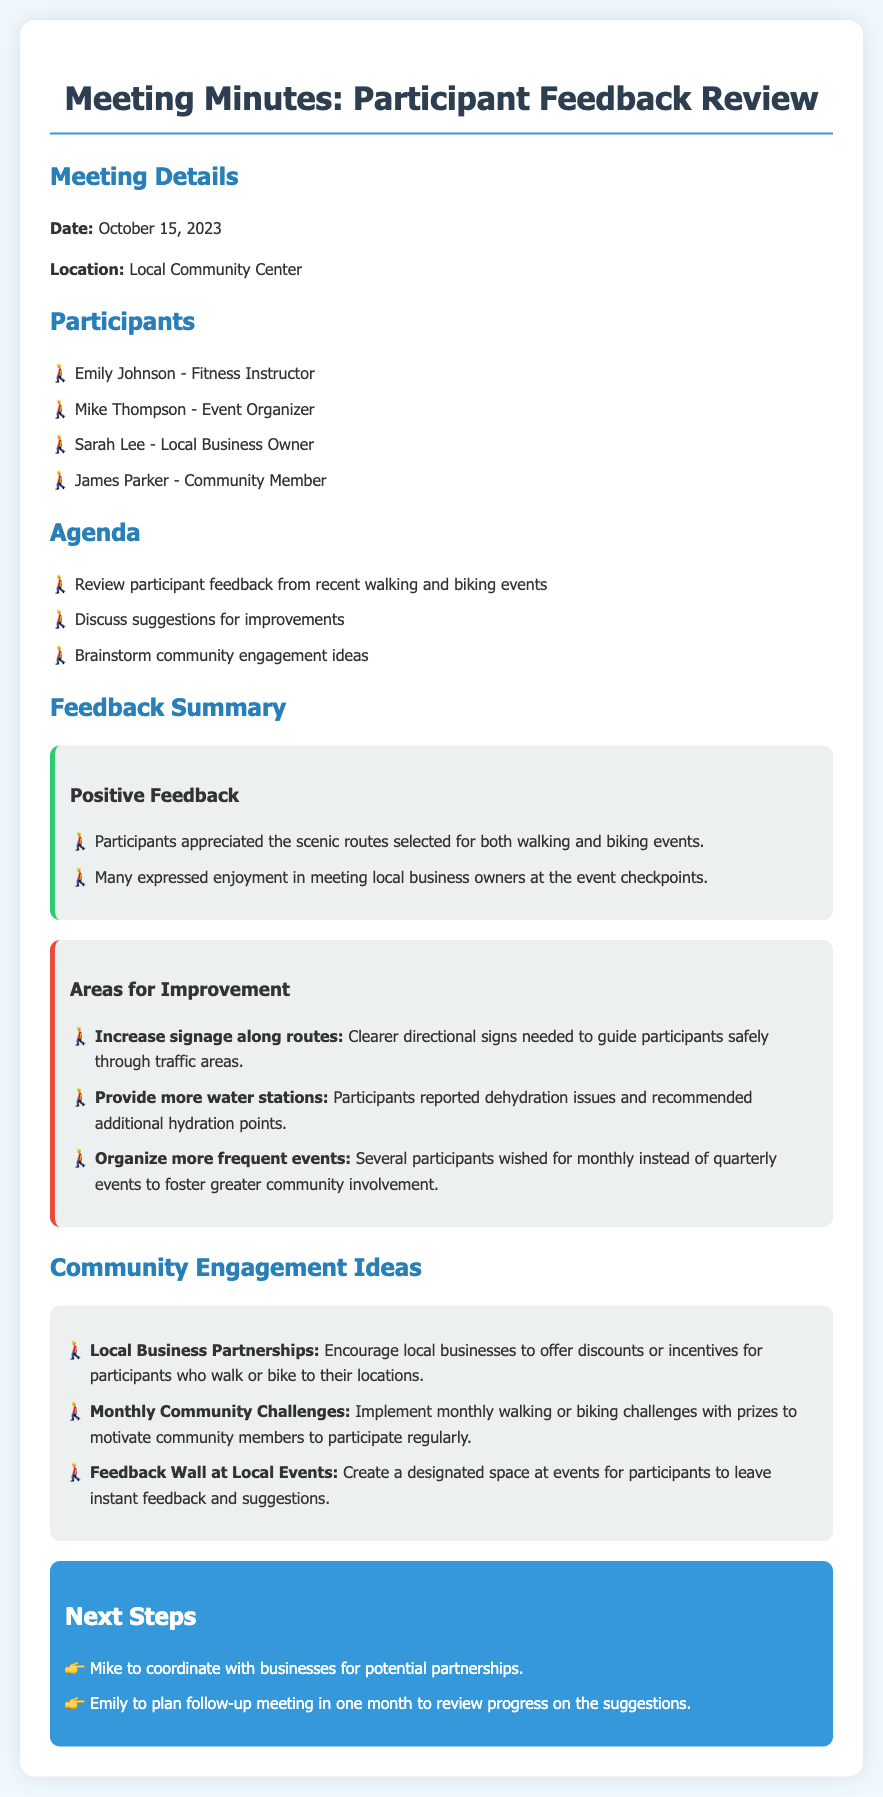What is the date of the meeting? The date of the meeting is provided in the meeting details section.
Answer: October 15, 2023 Who is the fitness instructor participating in the meeting? The participants section lists Emily Johnson as the fitness instructor.
Answer: Emily Johnson What is one suggestion for improvement mentioned in the document? The areas for improvement section lists specific suggestions made by participants.
Answer: Increase signage along routes How often do participants wish to have events? The participants expressed a desire for more frequent events, specified in their feedback.
Answer: Monthly What is one community engagement idea presented? The community engagement ideas section outlines various proposals made by participants.
Answer: Local Business Partnerships Who will coordinate with businesses for potential partnerships? The next steps section designates Mike to take on this responsibility.
Answer: Mike How many participants expressed enjoyment in meeting local business owners? This feedback is summarized in the positive feedback section, but the exact number is not specified.
Answer: Many What kind of challenges are suggested for community engagement? The community engagement ideas list includes specific types of challenges to motivate participation.
Answer: Monthly walking or biking challenges 